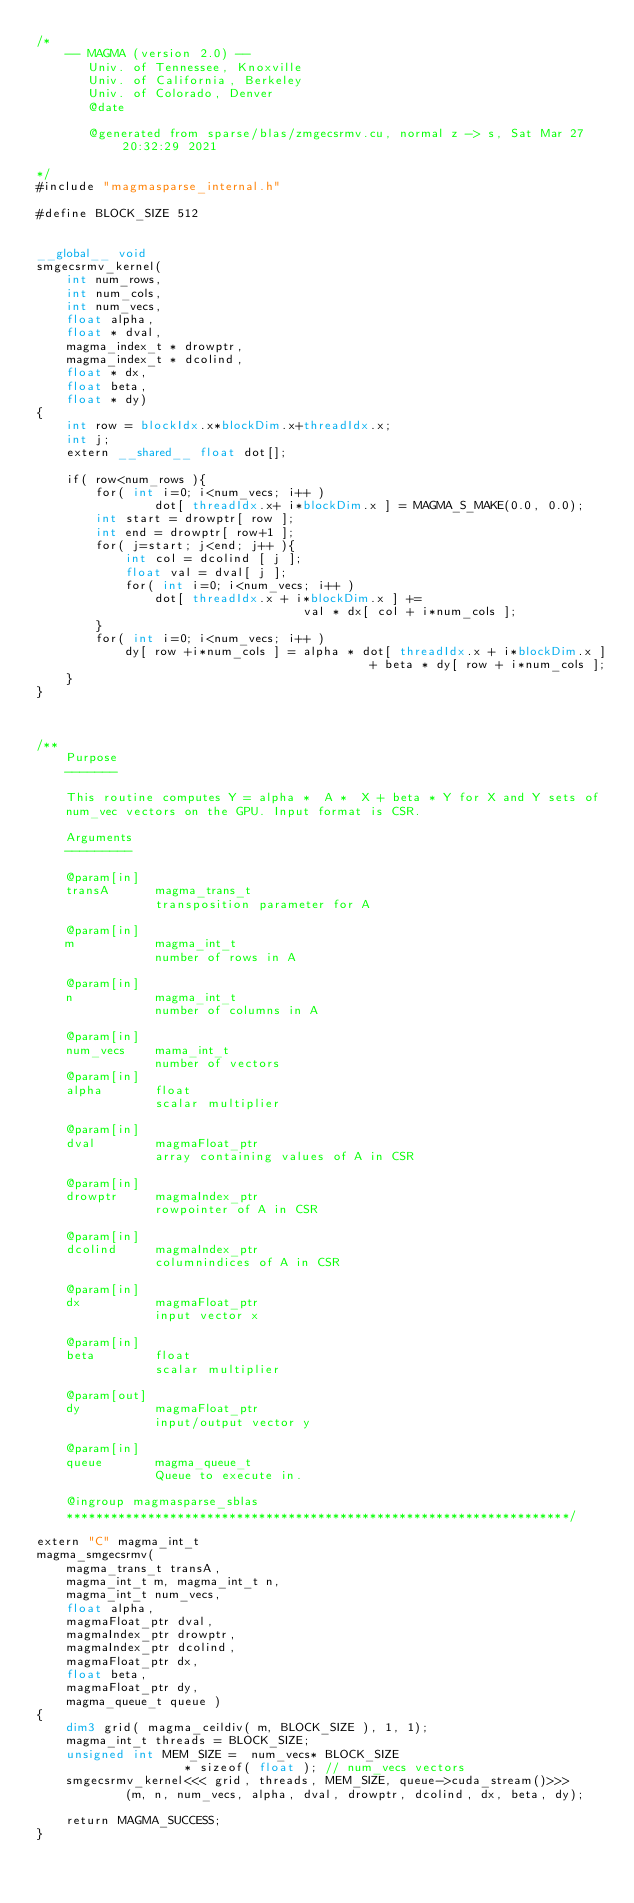Convert code to text. <code><loc_0><loc_0><loc_500><loc_500><_Cuda_>/*
    -- MAGMA (version 2.0) --
       Univ. of Tennessee, Knoxville
       Univ. of California, Berkeley
       Univ. of Colorado, Denver
       @date

       @generated from sparse/blas/zmgecsrmv.cu, normal z -> s, Sat Mar 27 20:32:29 2021

*/
#include "magmasparse_internal.h"

#define BLOCK_SIZE 512


__global__ void 
smgecsrmv_kernel( 
    int num_rows, 
    int num_cols, 
    int num_vecs,
    float alpha, 
    float * dval, 
    magma_index_t * drowptr, 
    magma_index_t * dcolind,
    float * dx,
    float beta, 
    float * dy)
{
    int row = blockIdx.x*blockDim.x+threadIdx.x;
    int j;
    extern __shared__ float dot[];

    if( row<num_rows ){
        for( int i=0; i<num_vecs; i++ )
                dot[ threadIdx.x+ i*blockDim.x ] = MAGMA_S_MAKE(0.0, 0.0);
        int start = drowptr[ row ];
        int end = drowptr[ row+1 ];
        for( j=start; j<end; j++ ){
            int col = dcolind [ j ];
            float val = dval[ j ];
            for( int i=0; i<num_vecs; i++ )
                dot[ threadIdx.x + i*blockDim.x ] += 
                                    val * dx[ col + i*num_cols ];
        }
        for( int i=0; i<num_vecs; i++ )
            dy[ row +i*num_cols ] = alpha * dot[ threadIdx.x + i*blockDim.x ] 
                                             + beta * dy[ row + i*num_cols ];
    }
}



/**
    Purpose
    -------
    
    This routine computes Y = alpha *  A *  X + beta * Y for X and Y sets of 
    num_vec vectors on the GPU. Input format is CSR. 
    
    Arguments
    ---------
    
    @param[in]
    transA      magma_trans_t
                transposition parameter for A

    @param[in]
    m           magma_int_t
                number of rows in A

    @param[in]
    n           magma_int_t
                number of columns in A 
                
    @param[in]
    num_vecs    mama_int_t
                number of vectors
    @param[in]
    alpha       float
                scalar multiplier

    @param[in]
    dval        magmaFloat_ptr
                array containing values of A in CSR

    @param[in]
    drowptr     magmaIndex_ptr
                rowpointer of A in CSR

    @param[in]
    dcolind     magmaIndex_ptr
                columnindices of A in CSR

    @param[in]
    dx          magmaFloat_ptr
                input vector x

    @param[in]
    beta        float
                scalar multiplier

    @param[out]
    dy          magmaFloat_ptr
                input/output vector y

    @param[in]
    queue       magma_queue_t
                Queue to execute in.

    @ingroup magmasparse_sblas
    ********************************************************************/

extern "C" magma_int_t
magma_smgecsrmv(
    magma_trans_t transA,
    magma_int_t m, magma_int_t n,
    magma_int_t num_vecs, 
    float alpha,
    magmaFloat_ptr dval,
    magmaIndex_ptr drowptr,
    magmaIndex_ptr dcolind,
    magmaFloat_ptr dx,
    float beta,
    magmaFloat_ptr dy,
    magma_queue_t queue )
{
    dim3 grid( magma_ceildiv( m, BLOCK_SIZE ), 1, 1);
    magma_int_t threads = BLOCK_SIZE;
    unsigned int MEM_SIZE =  num_vecs* BLOCK_SIZE 
                    * sizeof( float ); // num_vecs vectors 
    smgecsrmv_kernel<<< grid, threads, MEM_SIZE, queue->cuda_stream()>>>
            (m, n, num_vecs, alpha, dval, drowptr, dcolind, dx, beta, dy);

    return MAGMA_SUCCESS;
}
</code> 